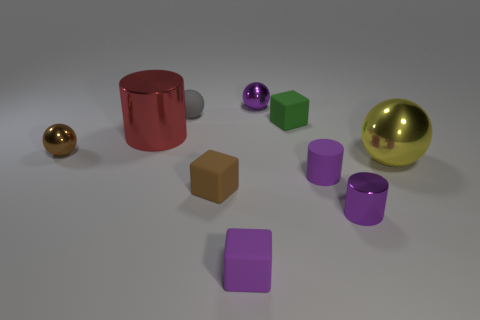Subtract all spheres. How many objects are left? 6 Subtract 0 yellow cylinders. How many objects are left? 10 Subtract all big red metal cylinders. Subtract all tiny blue metallic objects. How many objects are left? 9 Add 5 small green blocks. How many small green blocks are left? 6 Add 9 large brown shiny objects. How many large brown shiny objects exist? 9 